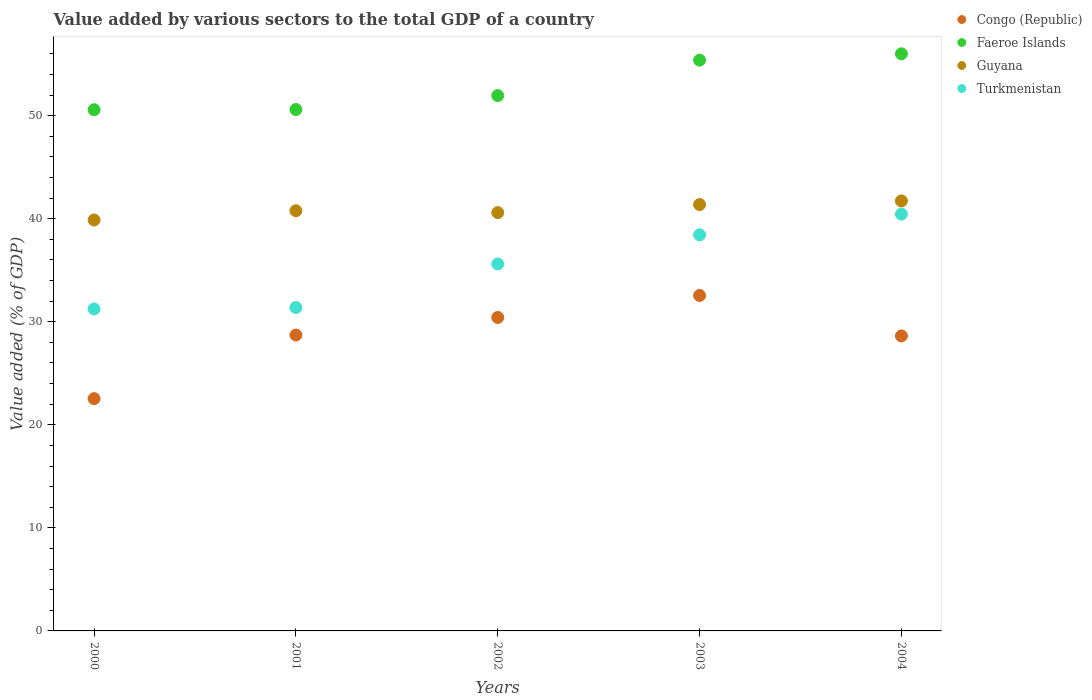How many different coloured dotlines are there?
Make the answer very short. 4. Is the number of dotlines equal to the number of legend labels?
Your answer should be very brief. Yes. What is the value added by various sectors to the total GDP in Guyana in 2003?
Your answer should be compact. 41.37. Across all years, what is the maximum value added by various sectors to the total GDP in Faeroe Islands?
Give a very brief answer. 56. Across all years, what is the minimum value added by various sectors to the total GDP in Turkmenistan?
Give a very brief answer. 31.24. In which year was the value added by various sectors to the total GDP in Guyana maximum?
Offer a terse response. 2004. What is the total value added by various sectors to the total GDP in Faeroe Islands in the graph?
Give a very brief answer. 264.5. What is the difference between the value added by various sectors to the total GDP in Faeroe Islands in 2001 and that in 2002?
Offer a terse response. -1.35. What is the difference between the value added by various sectors to the total GDP in Guyana in 2004 and the value added by various sectors to the total GDP in Faeroe Islands in 2002?
Provide a succinct answer. -10.22. What is the average value added by various sectors to the total GDP in Guyana per year?
Give a very brief answer. 40.87. In the year 2004, what is the difference between the value added by various sectors to the total GDP in Turkmenistan and value added by various sectors to the total GDP in Faeroe Islands?
Ensure brevity in your answer.  -15.55. What is the ratio of the value added by various sectors to the total GDP in Guyana in 2003 to that in 2004?
Provide a short and direct response. 0.99. Is the value added by various sectors to the total GDP in Faeroe Islands in 2000 less than that in 2001?
Give a very brief answer. Yes. What is the difference between the highest and the second highest value added by various sectors to the total GDP in Faeroe Islands?
Your answer should be very brief. 0.62. What is the difference between the highest and the lowest value added by various sectors to the total GDP in Turkmenistan?
Keep it short and to the point. 9.21. In how many years, is the value added by various sectors to the total GDP in Guyana greater than the average value added by various sectors to the total GDP in Guyana taken over all years?
Ensure brevity in your answer.  2. Is the sum of the value added by various sectors to the total GDP in Congo (Republic) in 2002 and 2004 greater than the maximum value added by various sectors to the total GDP in Guyana across all years?
Make the answer very short. Yes. Is it the case that in every year, the sum of the value added by various sectors to the total GDP in Congo (Republic) and value added by various sectors to the total GDP in Turkmenistan  is greater than the sum of value added by various sectors to the total GDP in Faeroe Islands and value added by various sectors to the total GDP in Guyana?
Ensure brevity in your answer.  No. Is it the case that in every year, the sum of the value added by various sectors to the total GDP in Turkmenistan and value added by various sectors to the total GDP in Guyana  is greater than the value added by various sectors to the total GDP in Congo (Republic)?
Your response must be concise. Yes. Does the value added by various sectors to the total GDP in Turkmenistan monotonically increase over the years?
Your answer should be very brief. Yes. How many years are there in the graph?
Offer a very short reply. 5. Does the graph contain any zero values?
Give a very brief answer. No. Where does the legend appear in the graph?
Your answer should be very brief. Top right. How many legend labels are there?
Offer a terse response. 4. How are the legend labels stacked?
Your answer should be very brief. Vertical. What is the title of the graph?
Make the answer very short. Value added by various sectors to the total GDP of a country. Does "Kazakhstan" appear as one of the legend labels in the graph?
Offer a very short reply. No. What is the label or title of the X-axis?
Offer a very short reply. Years. What is the label or title of the Y-axis?
Provide a short and direct response. Value added (% of GDP). What is the Value added (% of GDP) of Congo (Republic) in 2000?
Provide a short and direct response. 22.54. What is the Value added (% of GDP) in Faeroe Islands in 2000?
Make the answer very short. 50.58. What is the Value added (% of GDP) of Guyana in 2000?
Your answer should be compact. 39.88. What is the Value added (% of GDP) of Turkmenistan in 2000?
Ensure brevity in your answer.  31.24. What is the Value added (% of GDP) in Congo (Republic) in 2001?
Your answer should be compact. 28.71. What is the Value added (% of GDP) in Faeroe Islands in 2001?
Offer a terse response. 50.59. What is the Value added (% of GDP) of Guyana in 2001?
Your answer should be very brief. 40.78. What is the Value added (% of GDP) in Turkmenistan in 2001?
Give a very brief answer. 31.38. What is the Value added (% of GDP) in Congo (Republic) in 2002?
Provide a short and direct response. 30.42. What is the Value added (% of GDP) in Faeroe Islands in 2002?
Provide a succinct answer. 51.95. What is the Value added (% of GDP) in Guyana in 2002?
Your response must be concise. 40.59. What is the Value added (% of GDP) in Turkmenistan in 2002?
Your response must be concise. 35.61. What is the Value added (% of GDP) in Congo (Republic) in 2003?
Make the answer very short. 32.55. What is the Value added (% of GDP) in Faeroe Islands in 2003?
Ensure brevity in your answer.  55.39. What is the Value added (% of GDP) in Guyana in 2003?
Offer a terse response. 41.37. What is the Value added (% of GDP) in Turkmenistan in 2003?
Offer a terse response. 38.44. What is the Value added (% of GDP) in Congo (Republic) in 2004?
Your response must be concise. 28.63. What is the Value added (% of GDP) in Faeroe Islands in 2004?
Your answer should be compact. 56. What is the Value added (% of GDP) in Guyana in 2004?
Your answer should be very brief. 41.73. What is the Value added (% of GDP) in Turkmenistan in 2004?
Keep it short and to the point. 40.45. Across all years, what is the maximum Value added (% of GDP) in Congo (Republic)?
Offer a terse response. 32.55. Across all years, what is the maximum Value added (% of GDP) in Faeroe Islands?
Ensure brevity in your answer.  56. Across all years, what is the maximum Value added (% of GDP) in Guyana?
Ensure brevity in your answer.  41.73. Across all years, what is the maximum Value added (% of GDP) of Turkmenistan?
Keep it short and to the point. 40.45. Across all years, what is the minimum Value added (% of GDP) of Congo (Republic)?
Offer a very short reply. 22.54. Across all years, what is the minimum Value added (% of GDP) in Faeroe Islands?
Offer a very short reply. 50.58. Across all years, what is the minimum Value added (% of GDP) of Guyana?
Make the answer very short. 39.88. Across all years, what is the minimum Value added (% of GDP) in Turkmenistan?
Your answer should be very brief. 31.24. What is the total Value added (% of GDP) of Congo (Republic) in the graph?
Offer a very short reply. 142.85. What is the total Value added (% of GDP) of Faeroe Islands in the graph?
Keep it short and to the point. 264.5. What is the total Value added (% of GDP) of Guyana in the graph?
Give a very brief answer. 204.34. What is the total Value added (% of GDP) in Turkmenistan in the graph?
Offer a very short reply. 177.12. What is the difference between the Value added (% of GDP) in Congo (Republic) in 2000 and that in 2001?
Provide a short and direct response. -6.17. What is the difference between the Value added (% of GDP) of Faeroe Islands in 2000 and that in 2001?
Offer a terse response. -0.02. What is the difference between the Value added (% of GDP) in Guyana in 2000 and that in 2001?
Your response must be concise. -0.9. What is the difference between the Value added (% of GDP) of Turkmenistan in 2000 and that in 2001?
Provide a succinct answer. -0.14. What is the difference between the Value added (% of GDP) in Congo (Republic) in 2000 and that in 2002?
Provide a short and direct response. -7.88. What is the difference between the Value added (% of GDP) in Faeroe Islands in 2000 and that in 2002?
Give a very brief answer. -1.37. What is the difference between the Value added (% of GDP) in Guyana in 2000 and that in 2002?
Offer a very short reply. -0.72. What is the difference between the Value added (% of GDP) in Turkmenistan in 2000 and that in 2002?
Make the answer very short. -4.37. What is the difference between the Value added (% of GDP) in Congo (Republic) in 2000 and that in 2003?
Your response must be concise. -10.01. What is the difference between the Value added (% of GDP) of Faeroe Islands in 2000 and that in 2003?
Your answer should be compact. -4.81. What is the difference between the Value added (% of GDP) of Guyana in 2000 and that in 2003?
Your response must be concise. -1.5. What is the difference between the Value added (% of GDP) in Turkmenistan in 2000 and that in 2003?
Your answer should be very brief. -7.2. What is the difference between the Value added (% of GDP) in Congo (Republic) in 2000 and that in 2004?
Offer a terse response. -6.08. What is the difference between the Value added (% of GDP) in Faeroe Islands in 2000 and that in 2004?
Ensure brevity in your answer.  -5.43. What is the difference between the Value added (% of GDP) in Guyana in 2000 and that in 2004?
Make the answer very short. -1.85. What is the difference between the Value added (% of GDP) of Turkmenistan in 2000 and that in 2004?
Offer a terse response. -9.21. What is the difference between the Value added (% of GDP) in Congo (Republic) in 2001 and that in 2002?
Offer a terse response. -1.71. What is the difference between the Value added (% of GDP) in Faeroe Islands in 2001 and that in 2002?
Ensure brevity in your answer.  -1.35. What is the difference between the Value added (% of GDP) in Guyana in 2001 and that in 2002?
Your answer should be very brief. 0.18. What is the difference between the Value added (% of GDP) of Turkmenistan in 2001 and that in 2002?
Your answer should be very brief. -4.22. What is the difference between the Value added (% of GDP) in Congo (Republic) in 2001 and that in 2003?
Provide a short and direct response. -3.84. What is the difference between the Value added (% of GDP) of Faeroe Islands in 2001 and that in 2003?
Your answer should be very brief. -4.79. What is the difference between the Value added (% of GDP) in Guyana in 2001 and that in 2003?
Your response must be concise. -0.6. What is the difference between the Value added (% of GDP) in Turkmenistan in 2001 and that in 2003?
Provide a succinct answer. -7.05. What is the difference between the Value added (% of GDP) of Congo (Republic) in 2001 and that in 2004?
Ensure brevity in your answer.  0.09. What is the difference between the Value added (% of GDP) in Faeroe Islands in 2001 and that in 2004?
Make the answer very short. -5.41. What is the difference between the Value added (% of GDP) of Guyana in 2001 and that in 2004?
Keep it short and to the point. -0.95. What is the difference between the Value added (% of GDP) of Turkmenistan in 2001 and that in 2004?
Your response must be concise. -9.06. What is the difference between the Value added (% of GDP) in Congo (Republic) in 2002 and that in 2003?
Your answer should be compact. -2.13. What is the difference between the Value added (% of GDP) of Faeroe Islands in 2002 and that in 2003?
Provide a short and direct response. -3.44. What is the difference between the Value added (% of GDP) in Guyana in 2002 and that in 2003?
Keep it short and to the point. -0.78. What is the difference between the Value added (% of GDP) of Turkmenistan in 2002 and that in 2003?
Offer a terse response. -2.83. What is the difference between the Value added (% of GDP) of Congo (Republic) in 2002 and that in 2004?
Offer a very short reply. 1.79. What is the difference between the Value added (% of GDP) of Faeroe Islands in 2002 and that in 2004?
Your answer should be compact. -4.05. What is the difference between the Value added (% of GDP) of Guyana in 2002 and that in 2004?
Provide a short and direct response. -1.13. What is the difference between the Value added (% of GDP) in Turkmenistan in 2002 and that in 2004?
Your answer should be compact. -4.84. What is the difference between the Value added (% of GDP) of Congo (Republic) in 2003 and that in 2004?
Provide a succinct answer. 3.93. What is the difference between the Value added (% of GDP) in Faeroe Islands in 2003 and that in 2004?
Your answer should be very brief. -0.62. What is the difference between the Value added (% of GDP) of Guyana in 2003 and that in 2004?
Ensure brevity in your answer.  -0.35. What is the difference between the Value added (% of GDP) of Turkmenistan in 2003 and that in 2004?
Your answer should be compact. -2.01. What is the difference between the Value added (% of GDP) of Congo (Republic) in 2000 and the Value added (% of GDP) of Faeroe Islands in 2001?
Keep it short and to the point. -28.05. What is the difference between the Value added (% of GDP) in Congo (Republic) in 2000 and the Value added (% of GDP) in Guyana in 2001?
Your answer should be compact. -18.23. What is the difference between the Value added (% of GDP) of Congo (Republic) in 2000 and the Value added (% of GDP) of Turkmenistan in 2001?
Make the answer very short. -8.84. What is the difference between the Value added (% of GDP) in Faeroe Islands in 2000 and the Value added (% of GDP) in Guyana in 2001?
Your answer should be compact. 9.8. What is the difference between the Value added (% of GDP) in Faeroe Islands in 2000 and the Value added (% of GDP) in Turkmenistan in 2001?
Your response must be concise. 19.19. What is the difference between the Value added (% of GDP) of Guyana in 2000 and the Value added (% of GDP) of Turkmenistan in 2001?
Provide a succinct answer. 8.49. What is the difference between the Value added (% of GDP) of Congo (Republic) in 2000 and the Value added (% of GDP) of Faeroe Islands in 2002?
Your answer should be very brief. -29.4. What is the difference between the Value added (% of GDP) of Congo (Republic) in 2000 and the Value added (% of GDP) of Guyana in 2002?
Provide a short and direct response. -18.05. What is the difference between the Value added (% of GDP) in Congo (Republic) in 2000 and the Value added (% of GDP) in Turkmenistan in 2002?
Offer a very short reply. -13.07. What is the difference between the Value added (% of GDP) of Faeroe Islands in 2000 and the Value added (% of GDP) of Guyana in 2002?
Make the answer very short. 9.98. What is the difference between the Value added (% of GDP) of Faeroe Islands in 2000 and the Value added (% of GDP) of Turkmenistan in 2002?
Your response must be concise. 14.97. What is the difference between the Value added (% of GDP) of Guyana in 2000 and the Value added (% of GDP) of Turkmenistan in 2002?
Provide a succinct answer. 4.27. What is the difference between the Value added (% of GDP) of Congo (Republic) in 2000 and the Value added (% of GDP) of Faeroe Islands in 2003?
Keep it short and to the point. -32.84. What is the difference between the Value added (% of GDP) in Congo (Republic) in 2000 and the Value added (% of GDP) in Guyana in 2003?
Offer a very short reply. -18.83. What is the difference between the Value added (% of GDP) in Congo (Republic) in 2000 and the Value added (% of GDP) in Turkmenistan in 2003?
Offer a terse response. -15.89. What is the difference between the Value added (% of GDP) in Faeroe Islands in 2000 and the Value added (% of GDP) in Guyana in 2003?
Ensure brevity in your answer.  9.2. What is the difference between the Value added (% of GDP) of Faeroe Islands in 2000 and the Value added (% of GDP) of Turkmenistan in 2003?
Offer a terse response. 12.14. What is the difference between the Value added (% of GDP) in Guyana in 2000 and the Value added (% of GDP) in Turkmenistan in 2003?
Make the answer very short. 1.44. What is the difference between the Value added (% of GDP) in Congo (Republic) in 2000 and the Value added (% of GDP) in Faeroe Islands in 2004?
Give a very brief answer. -33.46. What is the difference between the Value added (% of GDP) in Congo (Republic) in 2000 and the Value added (% of GDP) in Guyana in 2004?
Keep it short and to the point. -19.18. What is the difference between the Value added (% of GDP) of Congo (Republic) in 2000 and the Value added (% of GDP) of Turkmenistan in 2004?
Offer a terse response. -17.91. What is the difference between the Value added (% of GDP) of Faeroe Islands in 2000 and the Value added (% of GDP) of Guyana in 2004?
Give a very brief answer. 8.85. What is the difference between the Value added (% of GDP) of Faeroe Islands in 2000 and the Value added (% of GDP) of Turkmenistan in 2004?
Offer a terse response. 10.13. What is the difference between the Value added (% of GDP) in Guyana in 2000 and the Value added (% of GDP) in Turkmenistan in 2004?
Ensure brevity in your answer.  -0.57. What is the difference between the Value added (% of GDP) of Congo (Republic) in 2001 and the Value added (% of GDP) of Faeroe Islands in 2002?
Provide a succinct answer. -23.24. What is the difference between the Value added (% of GDP) of Congo (Republic) in 2001 and the Value added (% of GDP) of Guyana in 2002?
Ensure brevity in your answer.  -11.88. What is the difference between the Value added (% of GDP) of Congo (Republic) in 2001 and the Value added (% of GDP) of Turkmenistan in 2002?
Provide a short and direct response. -6.9. What is the difference between the Value added (% of GDP) of Faeroe Islands in 2001 and the Value added (% of GDP) of Guyana in 2002?
Provide a short and direct response. 10. What is the difference between the Value added (% of GDP) in Faeroe Islands in 2001 and the Value added (% of GDP) in Turkmenistan in 2002?
Your response must be concise. 14.98. What is the difference between the Value added (% of GDP) of Guyana in 2001 and the Value added (% of GDP) of Turkmenistan in 2002?
Provide a short and direct response. 5.17. What is the difference between the Value added (% of GDP) in Congo (Republic) in 2001 and the Value added (% of GDP) in Faeroe Islands in 2003?
Your answer should be compact. -26.67. What is the difference between the Value added (% of GDP) of Congo (Republic) in 2001 and the Value added (% of GDP) of Guyana in 2003?
Provide a succinct answer. -12.66. What is the difference between the Value added (% of GDP) in Congo (Republic) in 2001 and the Value added (% of GDP) in Turkmenistan in 2003?
Provide a succinct answer. -9.73. What is the difference between the Value added (% of GDP) in Faeroe Islands in 2001 and the Value added (% of GDP) in Guyana in 2003?
Your answer should be very brief. 9.22. What is the difference between the Value added (% of GDP) of Faeroe Islands in 2001 and the Value added (% of GDP) of Turkmenistan in 2003?
Ensure brevity in your answer.  12.16. What is the difference between the Value added (% of GDP) of Guyana in 2001 and the Value added (% of GDP) of Turkmenistan in 2003?
Offer a terse response. 2.34. What is the difference between the Value added (% of GDP) of Congo (Republic) in 2001 and the Value added (% of GDP) of Faeroe Islands in 2004?
Offer a terse response. -27.29. What is the difference between the Value added (% of GDP) in Congo (Republic) in 2001 and the Value added (% of GDP) in Guyana in 2004?
Keep it short and to the point. -13.01. What is the difference between the Value added (% of GDP) in Congo (Republic) in 2001 and the Value added (% of GDP) in Turkmenistan in 2004?
Your answer should be compact. -11.74. What is the difference between the Value added (% of GDP) in Faeroe Islands in 2001 and the Value added (% of GDP) in Guyana in 2004?
Your answer should be compact. 8.87. What is the difference between the Value added (% of GDP) in Faeroe Islands in 2001 and the Value added (% of GDP) in Turkmenistan in 2004?
Make the answer very short. 10.14. What is the difference between the Value added (% of GDP) in Guyana in 2001 and the Value added (% of GDP) in Turkmenistan in 2004?
Keep it short and to the point. 0.33. What is the difference between the Value added (% of GDP) of Congo (Republic) in 2002 and the Value added (% of GDP) of Faeroe Islands in 2003?
Your response must be concise. -24.97. What is the difference between the Value added (% of GDP) in Congo (Republic) in 2002 and the Value added (% of GDP) in Guyana in 2003?
Provide a succinct answer. -10.95. What is the difference between the Value added (% of GDP) in Congo (Republic) in 2002 and the Value added (% of GDP) in Turkmenistan in 2003?
Provide a short and direct response. -8.02. What is the difference between the Value added (% of GDP) of Faeroe Islands in 2002 and the Value added (% of GDP) of Guyana in 2003?
Make the answer very short. 10.58. What is the difference between the Value added (% of GDP) of Faeroe Islands in 2002 and the Value added (% of GDP) of Turkmenistan in 2003?
Your response must be concise. 13.51. What is the difference between the Value added (% of GDP) in Guyana in 2002 and the Value added (% of GDP) in Turkmenistan in 2003?
Keep it short and to the point. 2.16. What is the difference between the Value added (% of GDP) of Congo (Republic) in 2002 and the Value added (% of GDP) of Faeroe Islands in 2004?
Keep it short and to the point. -25.58. What is the difference between the Value added (% of GDP) in Congo (Republic) in 2002 and the Value added (% of GDP) in Guyana in 2004?
Make the answer very short. -11.31. What is the difference between the Value added (% of GDP) of Congo (Republic) in 2002 and the Value added (% of GDP) of Turkmenistan in 2004?
Your answer should be compact. -10.03. What is the difference between the Value added (% of GDP) of Faeroe Islands in 2002 and the Value added (% of GDP) of Guyana in 2004?
Provide a short and direct response. 10.22. What is the difference between the Value added (% of GDP) of Faeroe Islands in 2002 and the Value added (% of GDP) of Turkmenistan in 2004?
Provide a succinct answer. 11.5. What is the difference between the Value added (% of GDP) in Guyana in 2002 and the Value added (% of GDP) in Turkmenistan in 2004?
Ensure brevity in your answer.  0.14. What is the difference between the Value added (% of GDP) in Congo (Republic) in 2003 and the Value added (% of GDP) in Faeroe Islands in 2004?
Provide a succinct answer. -23.45. What is the difference between the Value added (% of GDP) of Congo (Republic) in 2003 and the Value added (% of GDP) of Guyana in 2004?
Provide a succinct answer. -9.17. What is the difference between the Value added (% of GDP) in Congo (Republic) in 2003 and the Value added (% of GDP) in Turkmenistan in 2004?
Give a very brief answer. -7.9. What is the difference between the Value added (% of GDP) in Faeroe Islands in 2003 and the Value added (% of GDP) in Guyana in 2004?
Your response must be concise. 13.66. What is the difference between the Value added (% of GDP) in Faeroe Islands in 2003 and the Value added (% of GDP) in Turkmenistan in 2004?
Ensure brevity in your answer.  14.94. What is the difference between the Value added (% of GDP) in Guyana in 2003 and the Value added (% of GDP) in Turkmenistan in 2004?
Keep it short and to the point. 0.92. What is the average Value added (% of GDP) of Congo (Republic) per year?
Your response must be concise. 28.57. What is the average Value added (% of GDP) in Faeroe Islands per year?
Make the answer very short. 52.9. What is the average Value added (% of GDP) of Guyana per year?
Make the answer very short. 40.87. What is the average Value added (% of GDP) of Turkmenistan per year?
Offer a very short reply. 35.42. In the year 2000, what is the difference between the Value added (% of GDP) in Congo (Republic) and Value added (% of GDP) in Faeroe Islands?
Provide a short and direct response. -28.03. In the year 2000, what is the difference between the Value added (% of GDP) of Congo (Republic) and Value added (% of GDP) of Guyana?
Provide a short and direct response. -17.33. In the year 2000, what is the difference between the Value added (% of GDP) of Congo (Republic) and Value added (% of GDP) of Turkmenistan?
Provide a succinct answer. -8.7. In the year 2000, what is the difference between the Value added (% of GDP) of Faeroe Islands and Value added (% of GDP) of Guyana?
Make the answer very short. 10.7. In the year 2000, what is the difference between the Value added (% of GDP) of Faeroe Islands and Value added (% of GDP) of Turkmenistan?
Provide a short and direct response. 19.34. In the year 2000, what is the difference between the Value added (% of GDP) in Guyana and Value added (% of GDP) in Turkmenistan?
Give a very brief answer. 8.64. In the year 2001, what is the difference between the Value added (% of GDP) of Congo (Republic) and Value added (% of GDP) of Faeroe Islands?
Make the answer very short. -21.88. In the year 2001, what is the difference between the Value added (% of GDP) of Congo (Republic) and Value added (% of GDP) of Guyana?
Keep it short and to the point. -12.06. In the year 2001, what is the difference between the Value added (% of GDP) in Congo (Republic) and Value added (% of GDP) in Turkmenistan?
Make the answer very short. -2.67. In the year 2001, what is the difference between the Value added (% of GDP) in Faeroe Islands and Value added (% of GDP) in Guyana?
Ensure brevity in your answer.  9.82. In the year 2001, what is the difference between the Value added (% of GDP) in Faeroe Islands and Value added (% of GDP) in Turkmenistan?
Make the answer very short. 19.21. In the year 2001, what is the difference between the Value added (% of GDP) in Guyana and Value added (% of GDP) in Turkmenistan?
Provide a short and direct response. 9.39. In the year 2002, what is the difference between the Value added (% of GDP) of Congo (Republic) and Value added (% of GDP) of Faeroe Islands?
Make the answer very short. -21.53. In the year 2002, what is the difference between the Value added (% of GDP) of Congo (Republic) and Value added (% of GDP) of Guyana?
Offer a terse response. -10.17. In the year 2002, what is the difference between the Value added (% of GDP) in Congo (Republic) and Value added (% of GDP) in Turkmenistan?
Your answer should be very brief. -5.19. In the year 2002, what is the difference between the Value added (% of GDP) in Faeroe Islands and Value added (% of GDP) in Guyana?
Offer a terse response. 11.35. In the year 2002, what is the difference between the Value added (% of GDP) in Faeroe Islands and Value added (% of GDP) in Turkmenistan?
Provide a succinct answer. 16.34. In the year 2002, what is the difference between the Value added (% of GDP) of Guyana and Value added (% of GDP) of Turkmenistan?
Your response must be concise. 4.98. In the year 2003, what is the difference between the Value added (% of GDP) in Congo (Republic) and Value added (% of GDP) in Faeroe Islands?
Make the answer very short. -22.83. In the year 2003, what is the difference between the Value added (% of GDP) in Congo (Republic) and Value added (% of GDP) in Guyana?
Your answer should be compact. -8.82. In the year 2003, what is the difference between the Value added (% of GDP) of Congo (Republic) and Value added (% of GDP) of Turkmenistan?
Your answer should be compact. -5.88. In the year 2003, what is the difference between the Value added (% of GDP) in Faeroe Islands and Value added (% of GDP) in Guyana?
Provide a succinct answer. 14.01. In the year 2003, what is the difference between the Value added (% of GDP) of Faeroe Islands and Value added (% of GDP) of Turkmenistan?
Your answer should be very brief. 16.95. In the year 2003, what is the difference between the Value added (% of GDP) in Guyana and Value added (% of GDP) in Turkmenistan?
Give a very brief answer. 2.93. In the year 2004, what is the difference between the Value added (% of GDP) of Congo (Republic) and Value added (% of GDP) of Faeroe Islands?
Your answer should be very brief. -27.38. In the year 2004, what is the difference between the Value added (% of GDP) in Congo (Republic) and Value added (% of GDP) in Guyana?
Your response must be concise. -13.1. In the year 2004, what is the difference between the Value added (% of GDP) in Congo (Republic) and Value added (% of GDP) in Turkmenistan?
Make the answer very short. -11.82. In the year 2004, what is the difference between the Value added (% of GDP) of Faeroe Islands and Value added (% of GDP) of Guyana?
Provide a succinct answer. 14.28. In the year 2004, what is the difference between the Value added (% of GDP) in Faeroe Islands and Value added (% of GDP) in Turkmenistan?
Offer a very short reply. 15.55. In the year 2004, what is the difference between the Value added (% of GDP) in Guyana and Value added (% of GDP) in Turkmenistan?
Your answer should be very brief. 1.28. What is the ratio of the Value added (% of GDP) in Congo (Republic) in 2000 to that in 2001?
Give a very brief answer. 0.79. What is the ratio of the Value added (% of GDP) in Turkmenistan in 2000 to that in 2001?
Your response must be concise. 1. What is the ratio of the Value added (% of GDP) of Congo (Republic) in 2000 to that in 2002?
Provide a short and direct response. 0.74. What is the ratio of the Value added (% of GDP) of Faeroe Islands in 2000 to that in 2002?
Your answer should be compact. 0.97. What is the ratio of the Value added (% of GDP) of Guyana in 2000 to that in 2002?
Offer a terse response. 0.98. What is the ratio of the Value added (% of GDP) in Turkmenistan in 2000 to that in 2002?
Offer a terse response. 0.88. What is the ratio of the Value added (% of GDP) of Congo (Republic) in 2000 to that in 2003?
Your answer should be compact. 0.69. What is the ratio of the Value added (% of GDP) of Faeroe Islands in 2000 to that in 2003?
Provide a short and direct response. 0.91. What is the ratio of the Value added (% of GDP) in Guyana in 2000 to that in 2003?
Your response must be concise. 0.96. What is the ratio of the Value added (% of GDP) in Turkmenistan in 2000 to that in 2003?
Provide a short and direct response. 0.81. What is the ratio of the Value added (% of GDP) of Congo (Republic) in 2000 to that in 2004?
Keep it short and to the point. 0.79. What is the ratio of the Value added (% of GDP) in Faeroe Islands in 2000 to that in 2004?
Provide a short and direct response. 0.9. What is the ratio of the Value added (% of GDP) in Guyana in 2000 to that in 2004?
Give a very brief answer. 0.96. What is the ratio of the Value added (% of GDP) in Turkmenistan in 2000 to that in 2004?
Your answer should be compact. 0.77. What is the ratio of the Value added (% of GDP) of Congo (Republic) in 2001 to that in 2002?
Keep it short and to the point. 0.94. What is the ratio of the Value added (% of GDP) of Faeroe Islands in 2001 to that in 2002?
Your answer should be compact. 0.97. What is the ratio of the Value added (% of GDP) of Turkmenistan in 2001 to that in 2002?
Give a very brief answer. 0.88. What is the ratio of the Value added (% of GDP) in Congo (Republic) in 2001 to that in 2003?
Your answer should be very brief. 0.88. What is the ratio of the Value added (% of GDP) of Faeroe Islands in 2001 to that in 2003?
Give a very brief answer. 0.91. What is the ratio of the Value added (% of GDP) in Guyana in 2001 to that in 2003?
Your answer should be compact. 0.99. What is the ratio of the Value added (% of GDP) in Turkmenistan in 2001 to that in 2003?
Provide a succinct answer. 0.82. What is the ratio of the Value added (% of GDP) in Faeroe Islands in 2001 to that in 2004?
Your answer should be very brief. 0.9. What is the ratio of the Value added (% of GDP) of Guyana in 2001 to that in 2004?
Your response must be concise. 0.98. What is the ratio of the Value added (% of GDP) in Turkmenistan in 2001 to that in 2004?
Keep it short and to the point. 0.78. What is the ratio of the Value added (% of GDP) in Congo (Republic) in 2002 to that in 2003?
Your response must be concise. 0.93. What is the ratio of the Value added (% of GDP) of Faeroe Islands in 2002 to that in 2003?
Your response must be concise. 0.94. What is the ratio of the Value added (% of GDP) in Guyana in 2002 to that in 2003?
Keep it short and to the point. 0.98. What is the ratio of the Value added (% of GDP) in Turkmenistan in 2002 to that in 2003?
Make the answer very short. 0.93. What is the ratio of the Value added (% of GDP) in Congo (Republic) in 2002 to that in 2004?
Give a very brief answer. 1.06. What is the ratio of the Value added (% of GDP) of Faeroe Islands in 2002 to that in 2004?
Keep it short and to the point. 0.93. What is the ratio of the Value added (% of GDP) in Guyana in 2002 to that in 2004?
Give a very brief answer. 0.97. What is the ratio of the Value added (% of GDP) of Turkmenistan in 2002 to that in 2004?
Provide a succinct answer. 0.88. What is the ratio of the Value added (% of GDP) in Congo (Republic) in 2003 to that in 2004?
Ensure brevity in your answer.  1.14. What is the ratio of the Value added (% of GDP) of Faeroe Islands in 2003 to that in 2004?
Offer a very short reply. 0.99. What is the ratio of the Value added (% of GDP) of Guyana in 2003 to that in 2004?
Make the answer very short. 0.99. What is the ratio of the Value added (% of GDP) of Turkmenistan in 2003 to that in 2004?
Provide a succinct answer. 0.95. What is the difference between the highest and the second highest Value added (% of GDP) of Congo (Republic)?
Keep it short and to the point. 2.13. What is the difference between the highest and the second highest Value added (% of GDP) in Faeroe Islands?
Offer a very short reply. 0.62. What is the difference between the highest and the second highest Value added (% of GDP) of Guyana?
Ensure brevity in your answer.  0.35. What is the difference between the highest and the second highest Value added (% of GDP) in Turkmenistan?
Keep it short and to the point. 2.01. What is the difference between the highest and the lowest Value added (% of GDP) in Congo (Republic)?
Your answer should be very brief. 10.01. What is the difference between the highest and the lowest Value added (% of GDP) in Faeroe Islands?
Your response must be concise. 5.43. What is the difference between the highest and the lowest Value added (% of GDP) of Guyana?
Provide a short and direct response. 1.85. What is the difference between the highest and the lowest Value added (% of GDP) in Turkmenistan?
Provide a succinct answer. 9.21. 